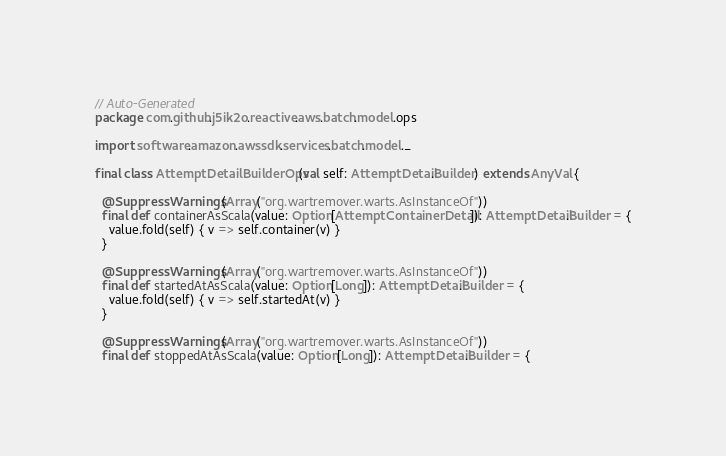<code> <loc_0><loc_0><loc_500><loc_500><_Scala_>// Auto-Generated
package com.github.j5ik2o.reactive.aws.batch.model.ops

import software.amazon.awssdk.services.batch.model._

final class AttemptDetailBuilderOps(val self: AttemptDetail.Builder) extends AnyVal {

  @SuppressWarnings(Array("org.wartremover.warts.AsInstanceOf"))
  final def containerAsScala(value: Option[AttemptContainerDetail]): AttemptDetail.Builder = {
    value.fold(self) { v => self.container(v) }
  }

  @SuppressWarnings(Array("org.wartremover.warts.AsInstanceOf"))
  final def startedAtAsScala(value: Option[Long]): AttemptDetail.Builder = {
    value.fold(self) { v => self.startedAt(v) }
  }

  @SuppressWarnings(Array("org.wartremover.warts.AsInstanceOf"))
  final def stoppedAtAsScala(value: Option[Long]): AttemptDetail.Builder = {</code> 